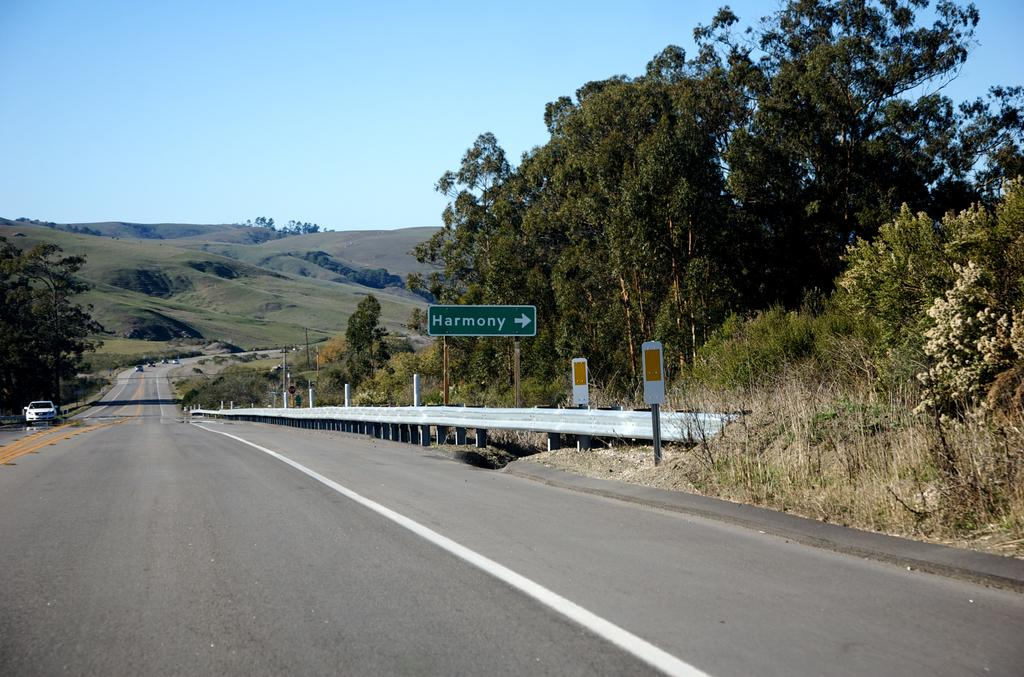What can be seen on the road in the image? There are vehicles on the road in the image. What is located on the right side of the image? There are boards on the right side of the image. What type of natural features can be seen in the background of the image? There are trees and mountains in the background of the image. What part of the natural environment is visible in the image? The sky is visible in the background of the image. What type of verse can be seen on the quilt in the image? There is no quilt or verse present in the image. How does the regret manifest itself in the image? There is no indication of regret in the image. 